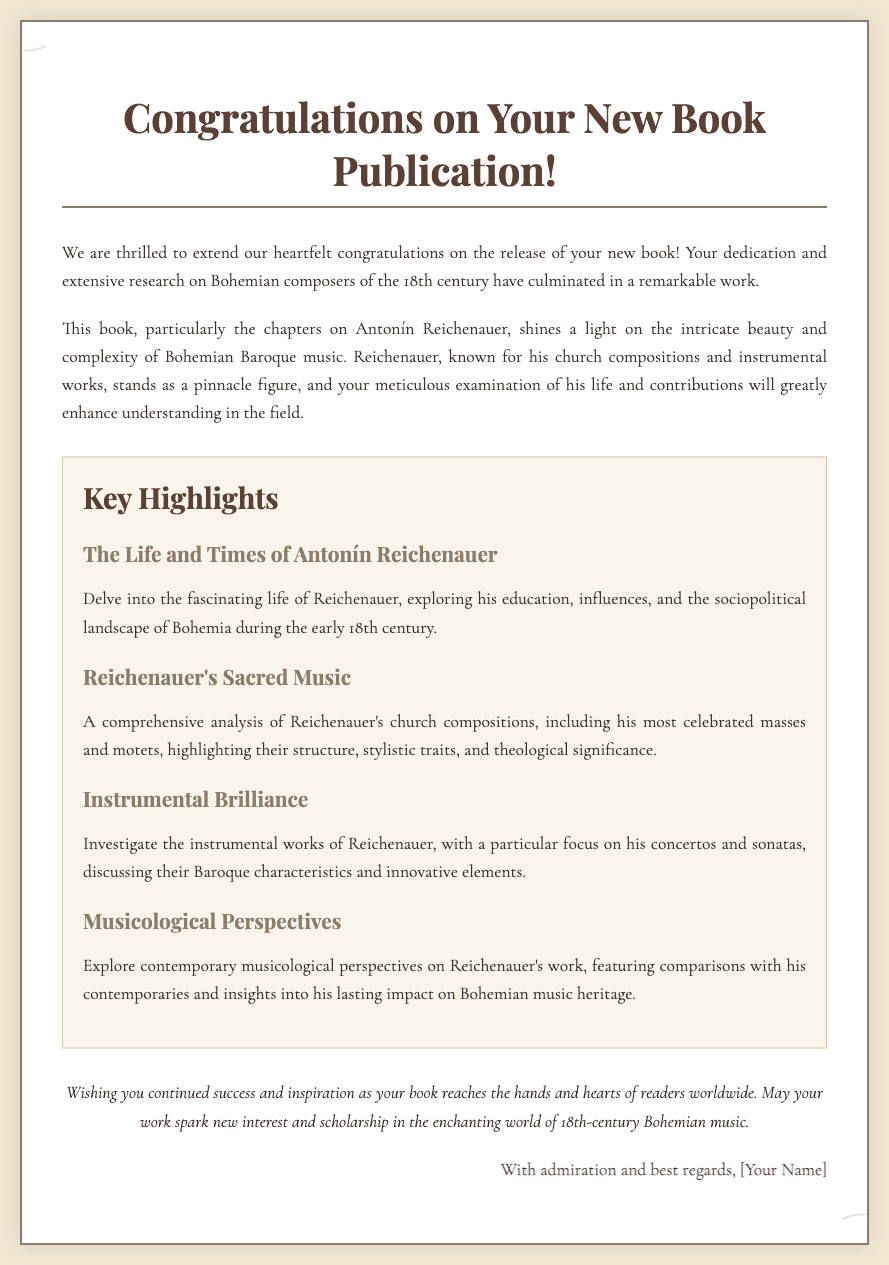What is the title of the book highlighted? The title mentioned in the document is "Congratulations on Your New Book Publication!" which emphasizes the book that is being celebrated.
Answer: Congratulations on Your New Book Publication! Who is the composer discussed in key chapters? The document specifically mentions Antonín Reichenauer as the composer highlighted in key chapters.
Answer: Antonín Reichenauer What is one type of music examined in relation to Reichenauer? The document discusses both sacred music and instrumental works, with a focus on Reichenauer's church compositions.
Answer: Sacred music How many key highlights are presented in the document? There are four key highlights listed that pertain to different aspects of Reichenauer's work.
Answer: Four What is the sentiment expressed in the closing statement? The closing wishes the author continued success and inspiration, reflecting a positive sentiment about the publication.
Answer: Success and inspiration What genre of music does Reichenauer primarily represent? The document places Reichenauer within the context of Baroque music, highlighting his contributions to that genre.
Answer: Baroque music What tone is used to congratulate the author? The greeting card employs a tone of heartfelt congratulations and admiration for the author's work.
Answer: Heartfelt congratulations What style element is the card decorated with? The document mentions that the card is ornamented with Baroque flourishes, reflecting the aesthetic tied to the subject matter.
Answer: Baroque flourishes 